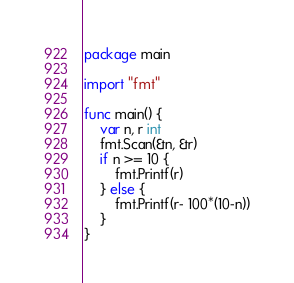<code> <loc_0><loc_0><loc_500><loc_500><_Go_>package main

import "fmt"

func main() {
	var n, r int
	fmt.Scan(&n, &r)
	if n >= 10 {
		fmt.Printf(r)
	} else {
		fmt.Printf(r- 100*(10-n))
	}
}</code> 